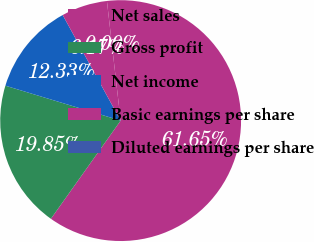Convert chart. <chart><loc_0><loc_0><loc_500><loc_500><pie_chart><fcel>Net sales<fcel>Gross profit<fcel>Net income<fcel>Basic earnings per share<fcel>Diluted earnings per share<nl><fcel>61.65%<fcel>19.85%<fcel>12.33%<fcel>6.17%<fcel>0.0%<nl></chart> 